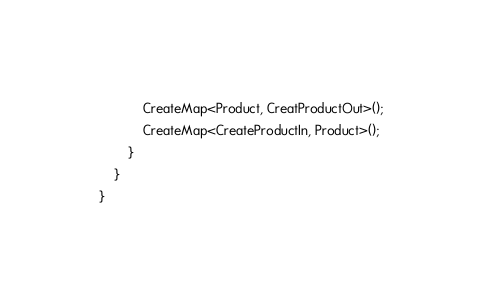Convert code to text. <code><loc_0><loc_0><loc_500><loc_500><_C#_>			CreateMap<Product, CreatProductOut>();
			CreateMap<CreateProductIn, Product>();
		}
	}
}</code> 